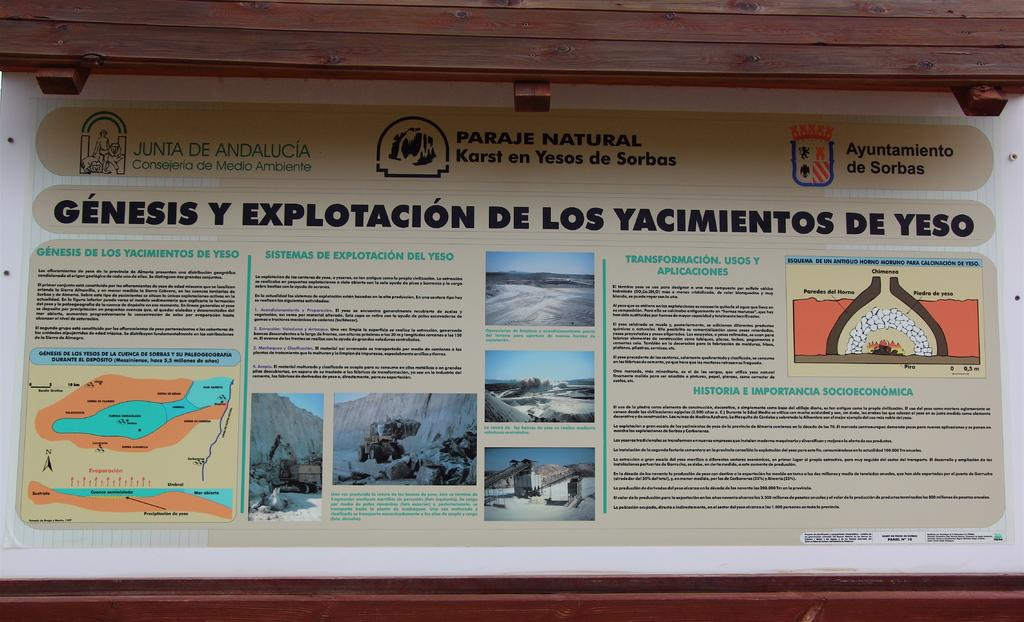<image>
Give a short and clear explanation of the subsequent image. A sign is stating Genesis Y Explotacion de los yacimientos de yeso. 